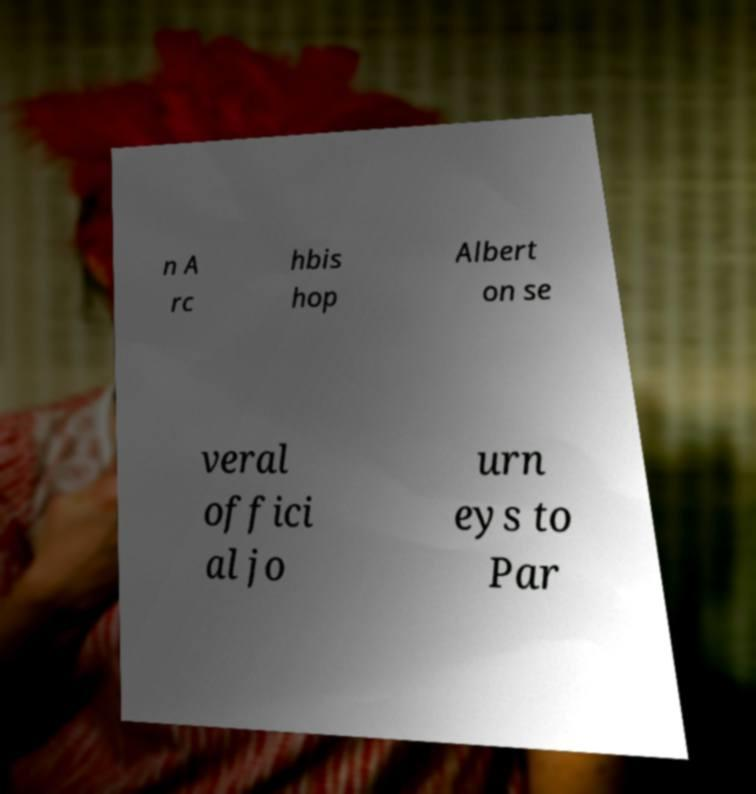What messages or text are displayed in this image? I need them in a readable, typed format. n A rc hbis hop Albert on se veral offici al jo urn eys to Par 